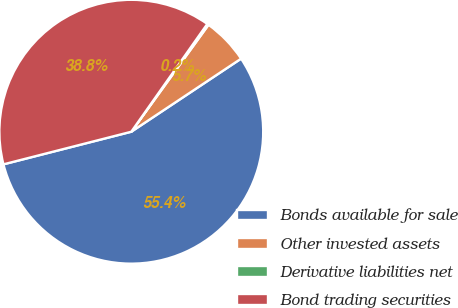Convert chart. <chart><loc_0><loc_0><loc_500><loc_500><pie_chart><fcel>Bonds available for sale<fcel>Other invested assets<fcel>Derivative liabilities net<fcel>Bond trading securities<nl><fcel>55.37%<fcel>5.7%<fcel>0.18%<fcel>38.75%<nl></chart> 